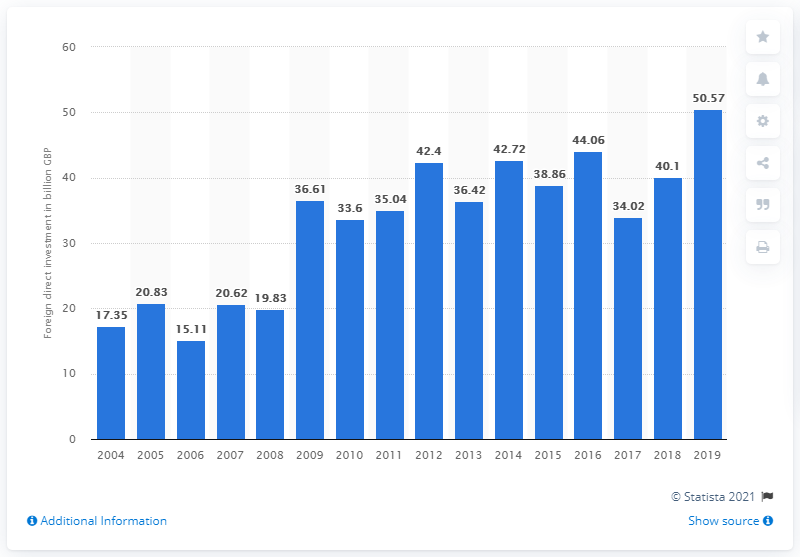Indicate a few pertinent items in this graphic. The amount of Foreign Direct Investment in Africa in 2019 was 50.57. 